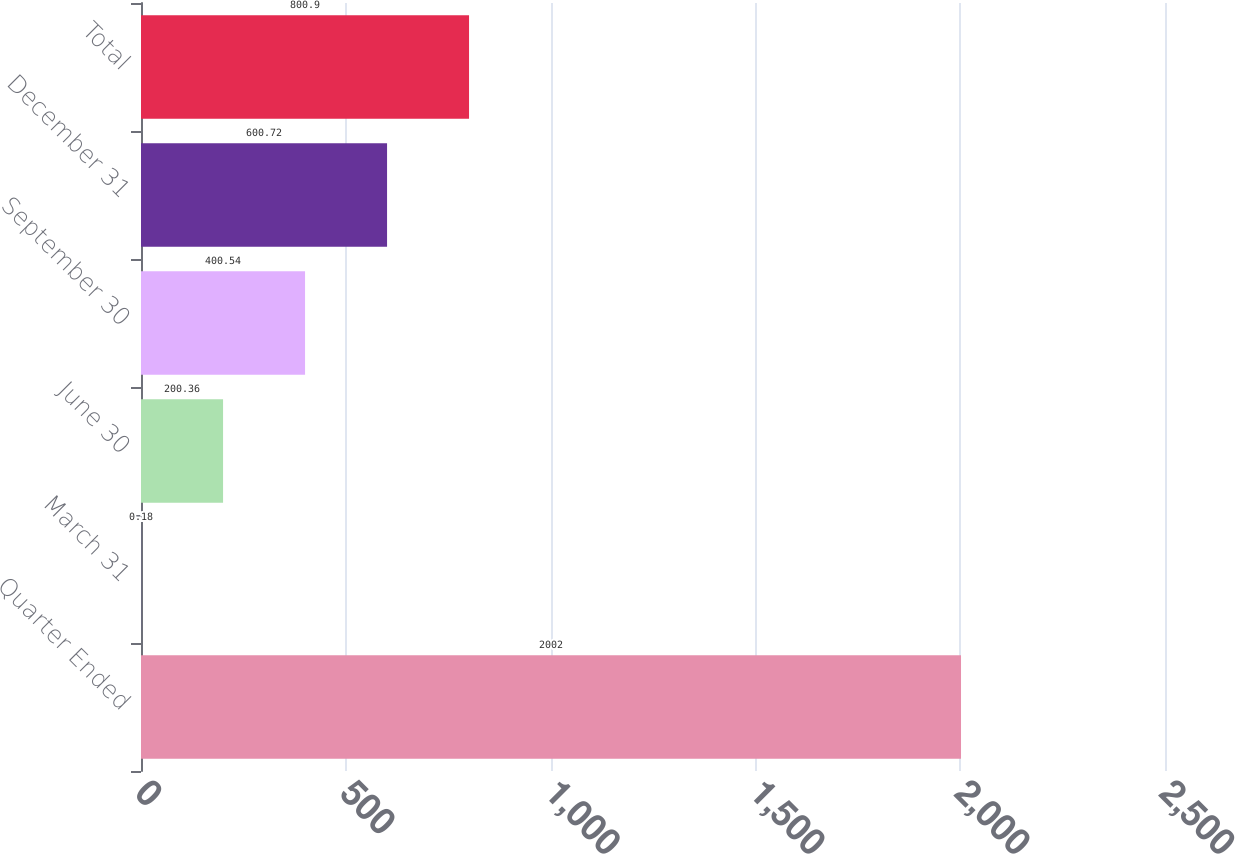Convert chart. <chart><loc_0><loc_0><loc_500><loc_500><bar_chart><fcel>Quarter Ended<fcel>March 31<fcel>June 30<fcel>September 30<fcel>December 31<fcel>Total<nl><fcel>2002<fcel>0.18<fcel>200.36<fcel>400.54<fcel>600.72<fcel>800.9<nl></chart> 